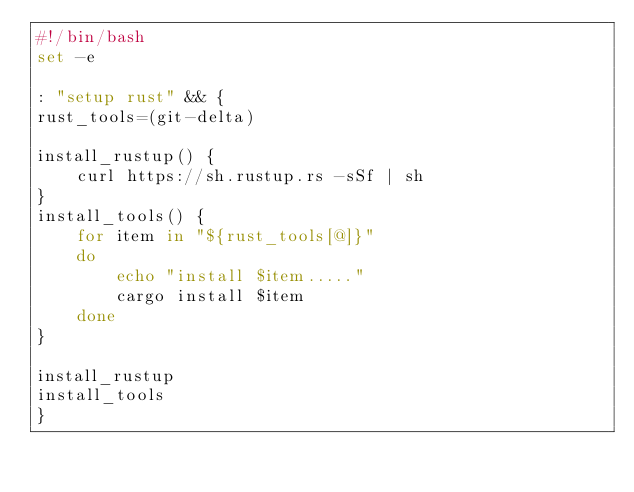Convert code to text. <code><loc_0><loc_0><loc_500><loc_500><_Bash_>#!/bin/bash
set -e

: "setup rust" && {
rust_tools=(git-delta)

install_rustup() {
    curl https://sh.rustup.rs -sSf | sh
}
install_tools() {
    for item in "${rust_tools[@]}"
    do 
        echo "install $item....."
        cargo install $item
    done
}

install_rustup
install_tools
}

</code> 